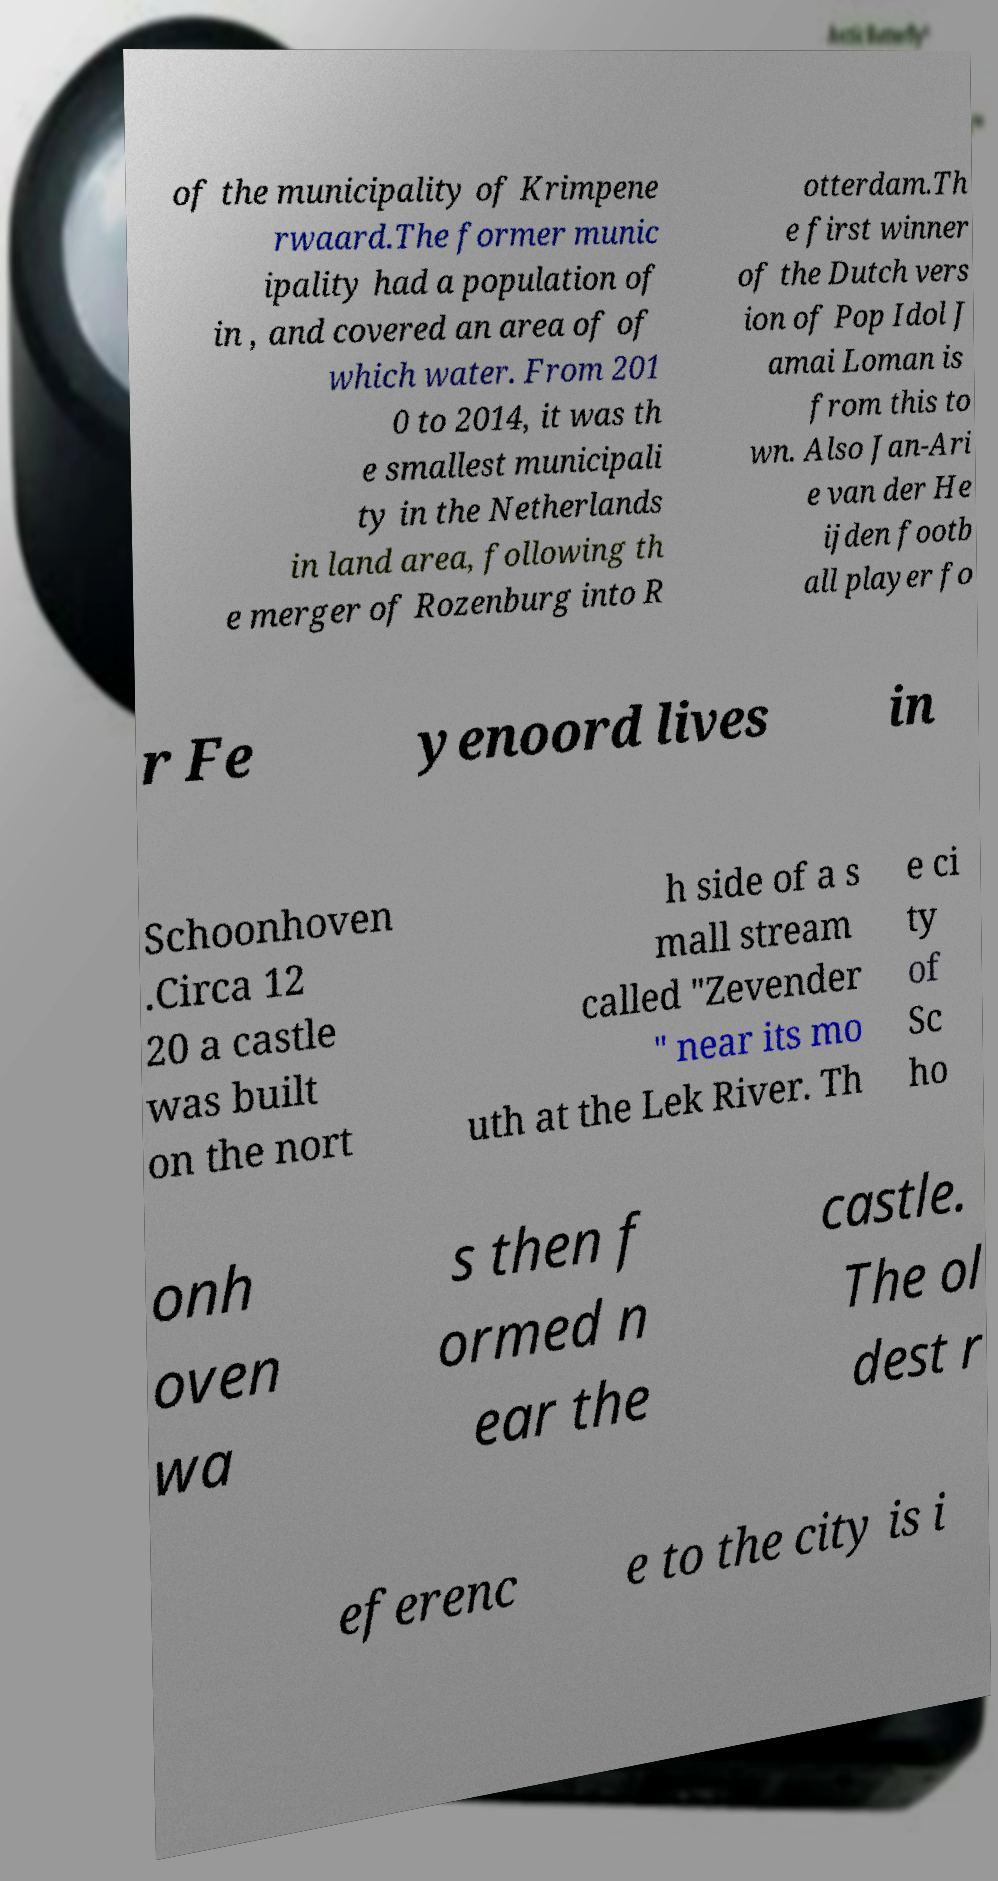Please identify and transcribe the text found in this image. of the municipality of Krimpene rwaard.The former munic ipality had a population of in , and covered an area of of which water. From 201 0 to 2014, it was th e smallest municipali ty in the Netherlands in land area, following th e merger of Rozenburg into R otterdam.Th e first winner of the Dutch vers ion of Pop Idol J amai Loman is from this to wn. Also Jan-Ari e van der He ijden footb all player fo r Fe yenoord lives in Schoonhoven .Circa 12 20 a castle was built on the nort h side of a s mall stream called "Zevender " near its mo uth at the Lek River. Th e ci ty of Sc ho onh oven wa s then f ormed n ear the castle. The ol dest r eferenc e to the city is i 